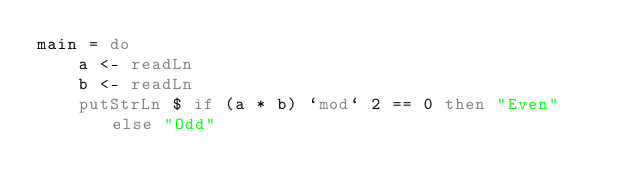<code> <loc_0><loc_0><loc_500><loc_500><_Haskell_>main = do
    a <- readLn
    b <- readLn
    putStrLn $ if (a * b) `mod` 2 == 0 then "Even" else "Odd"</code> 